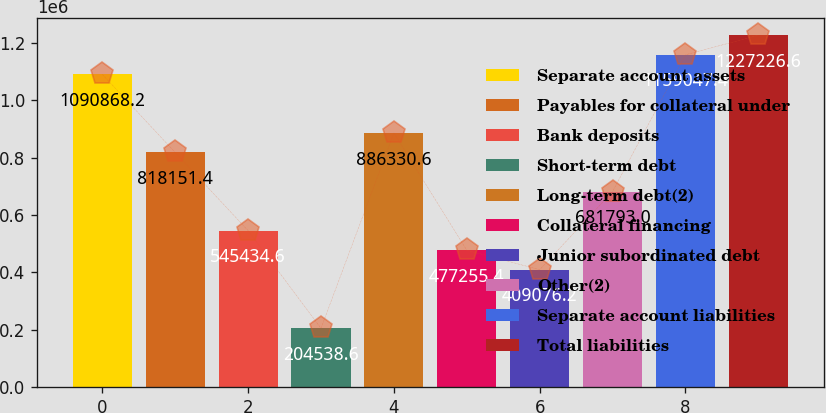<chart> <loc_0><loc_0><loc_500><loc_500><bar_chart><fcel>Separate account assets<fcel>Payables for collateral under<fcel>Bank deposits<fcel>Short-term debt<fcel>Long-term debt(2)<fcel>Collateral financing<fcel>Junior subordinated debt<fcel>Other(2)<fcel>Separate account liabilities<fcel>Total liabilities<nl><fcel>1.09087e+06<fcel>818151<fcel>545435<fcel>204539<fcel>886331<fcel>477255<fcel>409076<fcel>681793<fcel>1.15905e+06<fcel>1.22723e+06<nl></chart> 